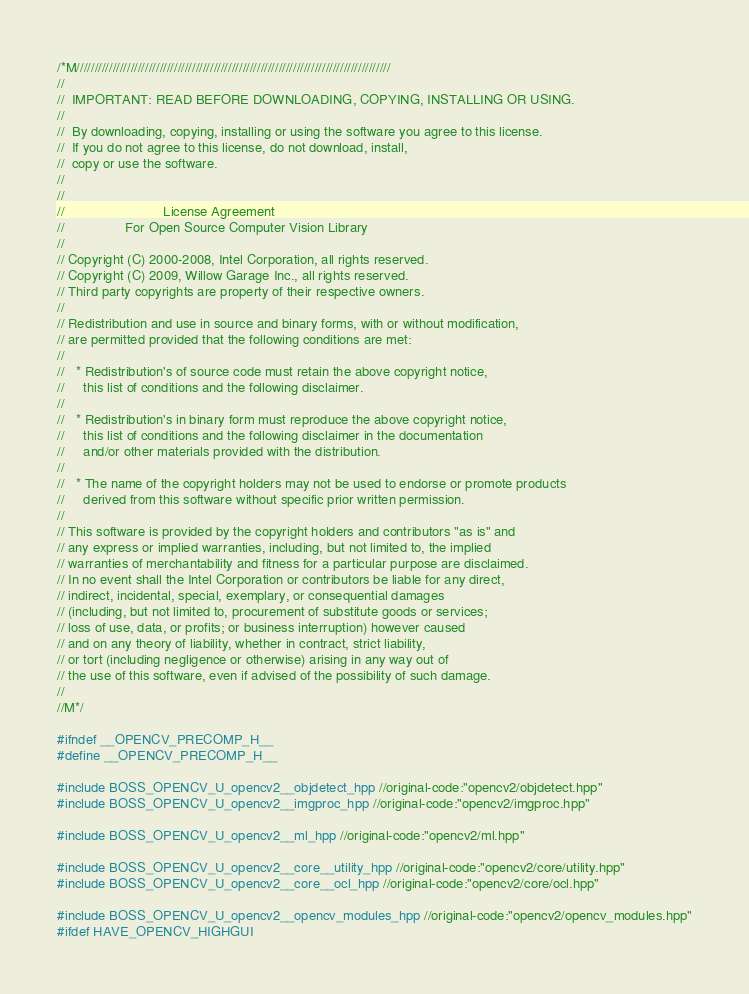<code> <loc_0><loc_0><loc_500><loc_500><_C++_>/*M///////////////////////////////////////////////////////////////////////////////////////
//
//  IMPORTANT: READ BEFORE DOWNLOADING, COPYING, INSTALLING OR USING.
//
//  By downloading, copying, installing or using the software you agree to this license.
//  If you do not agree to this license, do not download, install,
//  copy or use the software.
//
//
//                          License Agreement
//                For Open Source Computer Vision Library
//
// Copyright (C) 2000-2008, Intel Corporation, all rights reserved.
// Copyright (C) 2009, Willow Garage Inc., all rights reserved.
// Third party copyrights are property of their respective owners.
//
// Redistribution and use in source and binary forms, with or without modification,
// are permitted provided that the following conditions are met:
//
//   * Redistribution's of source code must retain the above copyright notice,
//     this list of conditions and the following disclaimer.
//
//   * Redistribution's in binary form must reproduce the above copyright notice,
//     this list of conditions and the following disclaimer in the documentation
//     and/or other materials provided with the distribution.
//
//   * The name of the copyright holders may not be used to endorse or promote products
//     derived from this software without specific prior written permission.
//
// This software is provided by the copyright holders and contributors "as is" and
// any express or implied warranties, including, but not limited to, the implied
// warranties of merchantability and fitness for a particular purpose are disclaimed.
// In no event shall the Intel Corporation or contributors be liable for any direct,
// indirect, incidental, special, exemplary, or consequential damages
// (including, but not limited to, procurement of substitute goods or services;
// loss of use, data, or profits; or business interruption) however caused
// and on any theory of liability, whether in contract, strict liability,
// or tort (including negligence or otherwise) arising in any way out of
// the use of this software, even if advised of the possibility of such damage.
//
//M*/

#ifndef __OPENCV_PRECOMP_H__
#define __OPENCV_PRECOMP_H__

#include BOSS_OPENCV_U_opencv2__objdetect_hpp //original-code:"opencv2/objdetect.hpp"
#include BOSS_OPENCV_U_opencv2__imgproc_hpp //original-code:"opencv2/imgproc.hpp"

#include BOSS_OPENCV_U_opencv2__ml_hpp //original-code:"opencv2/ml.hpp"

#include BOSS_OPENCV_U_opencv2__core__utility_hpp //original-code:"opencv2/core/utility.hpp"
#include BOSS_OPENCV_U_opencv2__core__ocl_hpp //original-code:"opencv2/core/ocl.hpp"

#include BOSS_OPENCV_U_opencv2__opencv_modules_hpp //original-code:"opencv2/opencv_modules.hpp"
#ifdef HAVE_OPENCV_HIGHGUI</code> 